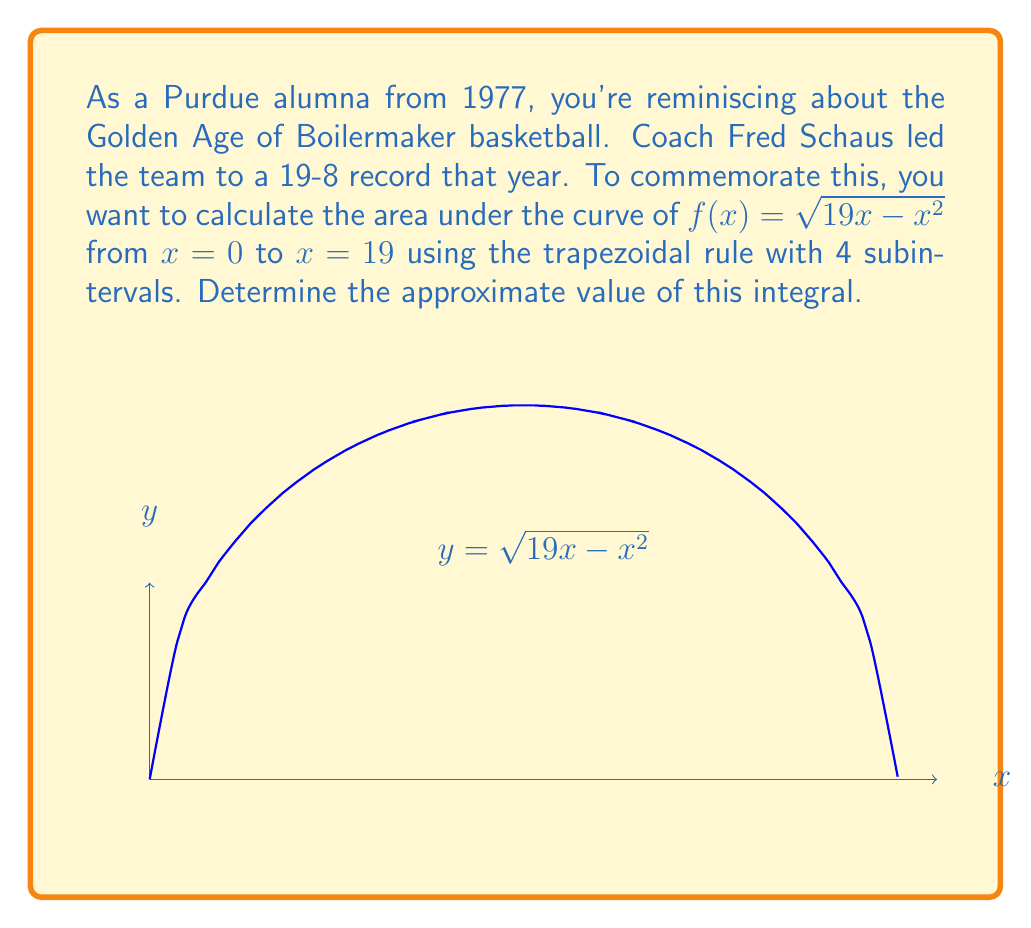Teach me how to tackle this problem. Let's approach this step-by-step:

1) The trapezoidal rule for n subintervals is given by:

   $$\int_a^b f(x) dx \approx \frac{h}{2}[f(x_0) + 2f(x_1) + 2f(x_2) + ... + 2f(x_{n-1}) + f(x_n)]$$

   where $h = \frac{b-a}{n}$, and $x_i = a + ih$ for $i = 0, 1, ..., n$

2) Here, $a = 0$, $b = 19$, and $n = 4$. So, $h = \frac{19-0}{4} = 4.75$

3) We need to calculate $f(x)$ at $x = 0, 4.75, 9.5, 14.25,$ and $19$:

   $f(0) = \sqrt{19(0) - 0^2} = 0$
   $f(4.75) = \sqrt{19(4.75) - 4.75^2} = \sqrt{67.6875} \approx 8.2273$
   $f(9.5) = \sqrt{19(9.5) - 9.5^2} = \sqrt{90.25} = 9.5$
   $f(14.25) = \sqrt{19(14.25) - 14.25^2} = \sqrt{67.6875} \approx 8.2273$
   $f(19) = \sqrt{19(19) - 19^2} = 0$

4) Applying the trapezoidal rule:

   $$\int_0^{19} \sqrt{19x - x^2} dx \approx \frac{4.75}{2}[0 + 2(8.2273) + 2(9.5) + 2(8.2273) + 0]$$

5) Simplifying:
   
   $$\approx 2.375[0 + 16.4546 + 19 + 16.4546] = 2.375(51.9092) = 123.2844$$

Thus, the approximate value of the integral using the trapezoidal rule with 4 subintervals is 123.2844.
Answer: $123.2844$ 